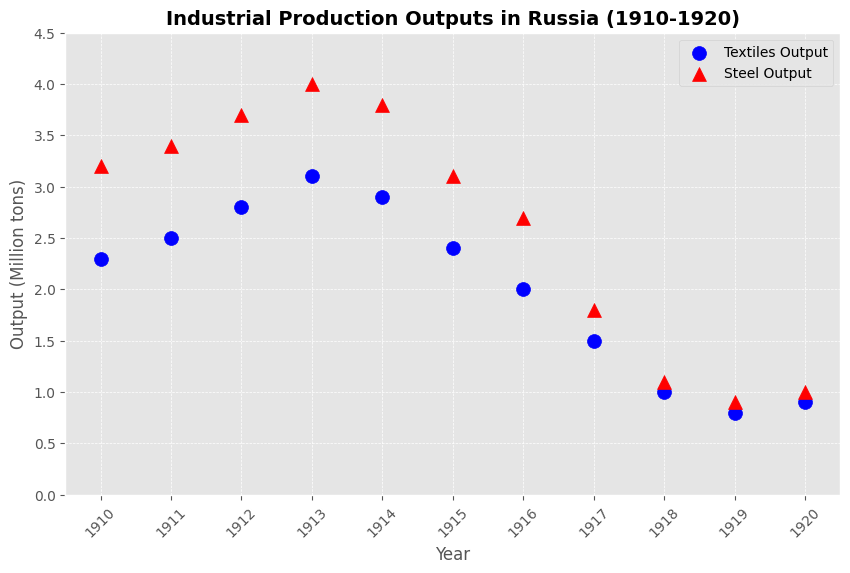Which year did steel output see the biggest drop compared to the previous year? To find the year with the biggest drop, observe the trend in steel output from year to year. The largest decline is from 1916 to 1917, where it decreases from 2.7 million tons to 1.8 million tons, a drop of 0.9 million tons.
Answer: 1917 By how much did textile output decrease from 1910 to 1918? To find the decrease, subtract the output in 1918 from the output in 1910. It dropped from 2.3 million tons in 1910 to 1.0 million tons in 1918, which is a decrease of 1.3 million tons.
Answer: 1.3 million tons In which year were the textile and steel outputs the closest in value? Compare the textual and steel output values for each year to find the smallest difference. In 1920, the textile output was 0.9 million tons and the steel output was 1.0 million tons, a difference of 0.1 million tons.
Answer: 1920 Between 1913 and 1914, did textile output decrease by more or less than steel output? Compare the decrease in outputs between 1913 and 1914. Textile output decreased from 3.1 to 2.9 million tons (a decrease of 0.2 million tons), and steel output decreased from 4.0 to 3.8 million tons (a decrease of 0.2 million tons). The decreases are equal.
Answer: Equal What was the average steel output during 1917 to 1920? To find the average, sum the steel outputs from 1917 (1.8), 1918 (1.1), 1919 (0.9), and 1920 (1.0), and divide by 4. The sum is 4.8 million tons, and the average is 4.8/4 = 1.2 million tons.
Answer: 1.2 million tons Was there any year when textile output increased compared to the previous year? Check for any years where textile output shows an increase from the previous year. The only increase is from 1919 (0.8 million tons) to 1920 (0.9 million tons).
Answer: Yes, in 1920 What is the total decrease in steel output from its highest value to its lowest value during the period? Identify the highest and lowest values of steel output. The highest is 4.0 million tons in 1913, and the lowest is 0.9 million tons in 1919. The total decrease is 4.0 - 0.9 = 3.1 million tons.
Answer: 3.1 million tons In which year did both textile and steel outputs experience their lowest values? Determine the year in which both outputs were at their minimum. Steel output was lowest in 1919 at 0.9 million tons, and textile output was lowest in 1918 at 1.0 million tons. The outputs in 1919 are both at their lowest when considering the data span.
Answer: 1919 